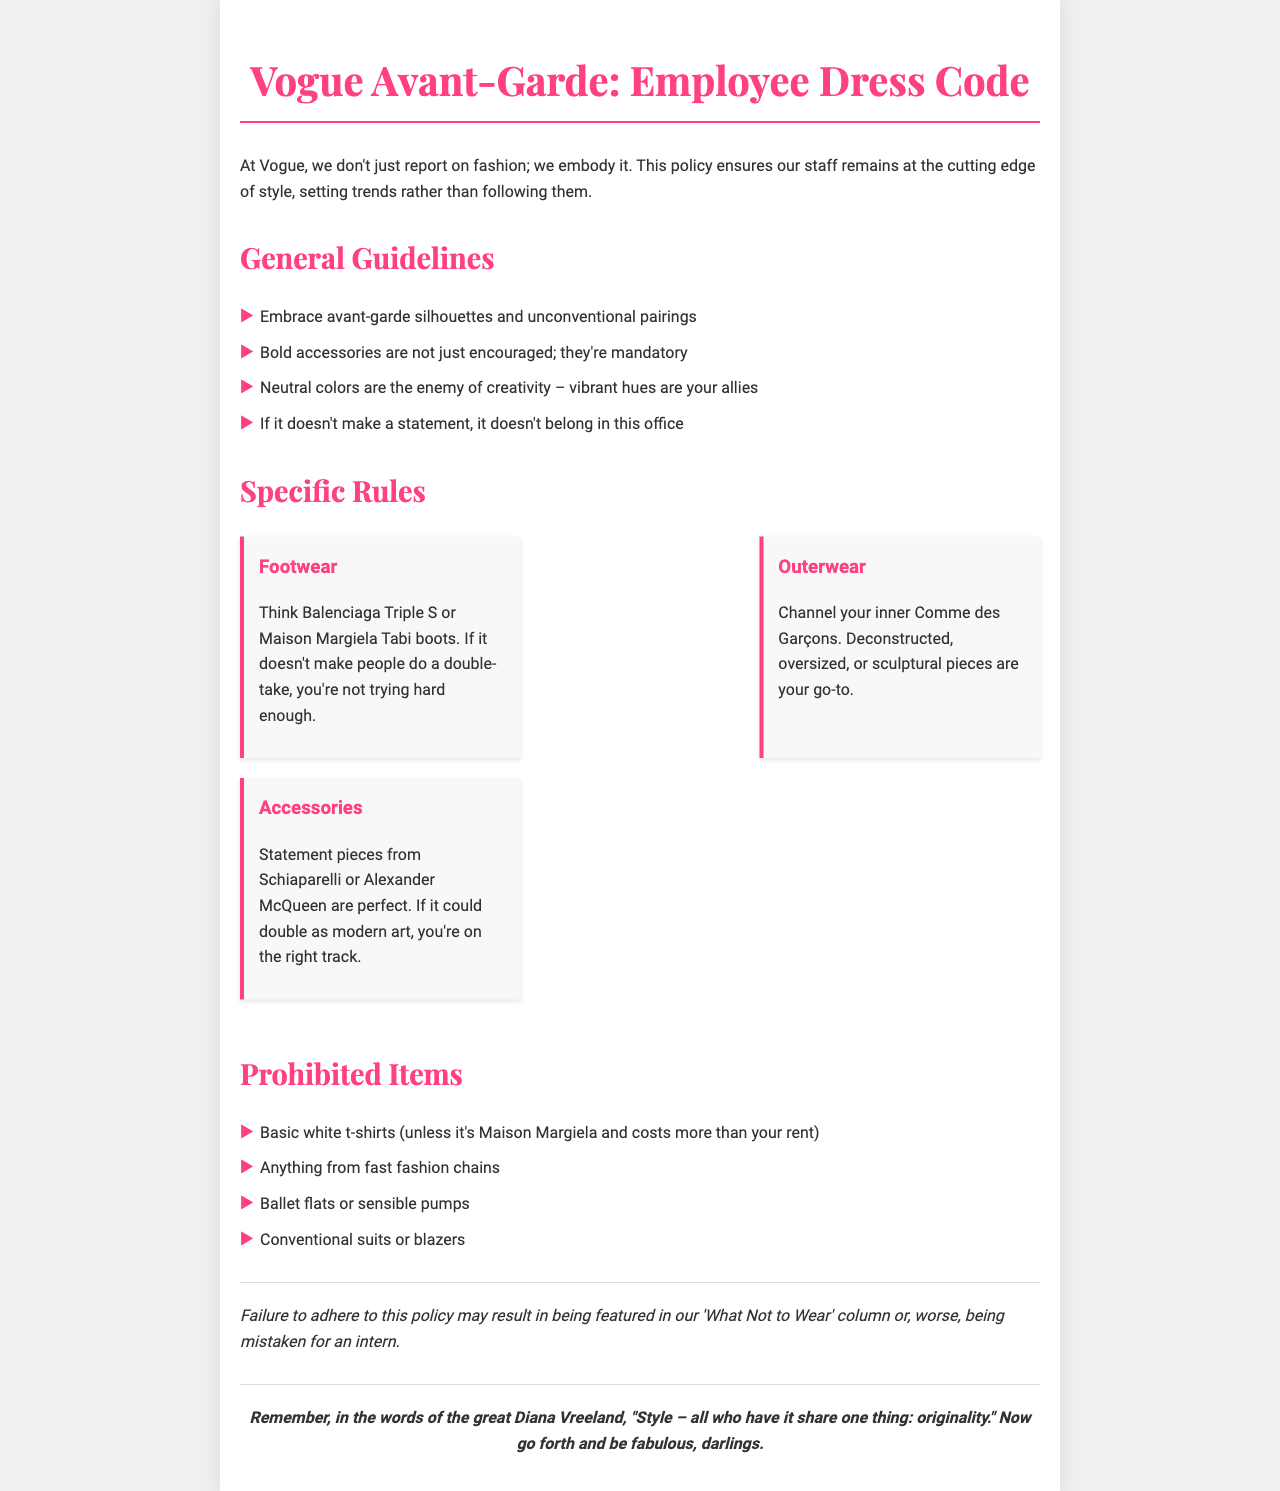what is the title of the document? The title is prominently displayed at the top of the document, indicating its focus on dress code for Vogue employees.
Answer: Vogue Avant-Garde: Employee Dress Code what type of colors are encouraged? The document specifies that vibrant hues are encouraged, contrasting them with neutral colors, which are deemed the enemy of creativity.
Answer: Vibrant hues what are employees encouraged to wear? The general guidelines state that employees should embrace avant-garde silhouettes and unconventional pairings.
Answer: Avant-garde silhouettes and unconventional pairings what footwear brand is mentioned as an example? The footnotes provide specific examples of footwear brands that align with the dress code, reflecting the avant-garde theme.
Answer: Balenciaga Triple S what item is prohibited according to the dress code? The listed prohibited items include clothing that is considered too conventional or from less fashionable sources, specifically mentioned in the document.
Answer: Basic white t-shirts what kind of outerwear is suggested? The document advises employees to channel their inner designer, recommending specific styles for outerwear that align with the fashion-forward emphasis.
Answer: Deconstructed, oversized, or sculptural pieces what may happen if someone fails to follow the dress code? The consequences section of the document outlines potential repercussions for not adhering to the dress code, illustrating the stakes involved.
Answer: Featured in 'What Not to Wear' column who is quoted about style in the closing statement? The document ends with a powerful quotation about originality in style from a notable fashion icon, emphasizing the overall message of creative expression.
Answer: Diana Vreeland 